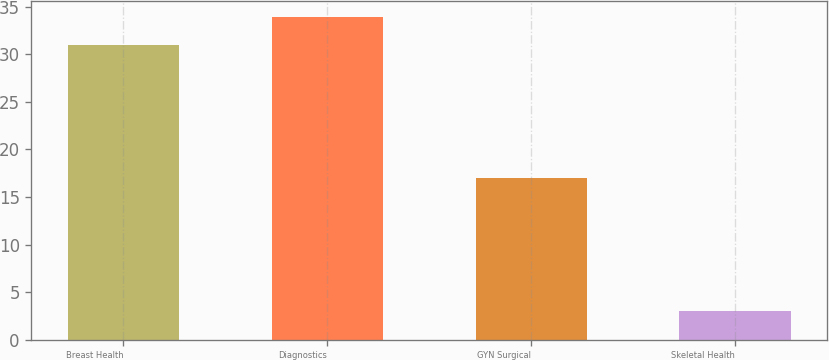<chart> <loc_0><loc_0><loc_500><loc_500><bar_chart><fcel>Breast Health<fcel>Diagnostics<fcel>GYN Surgical<fcel>Skeletal Health<nl><fcel>31<fcel>33.9<fcel>17<fcel>3<nl></chart> 